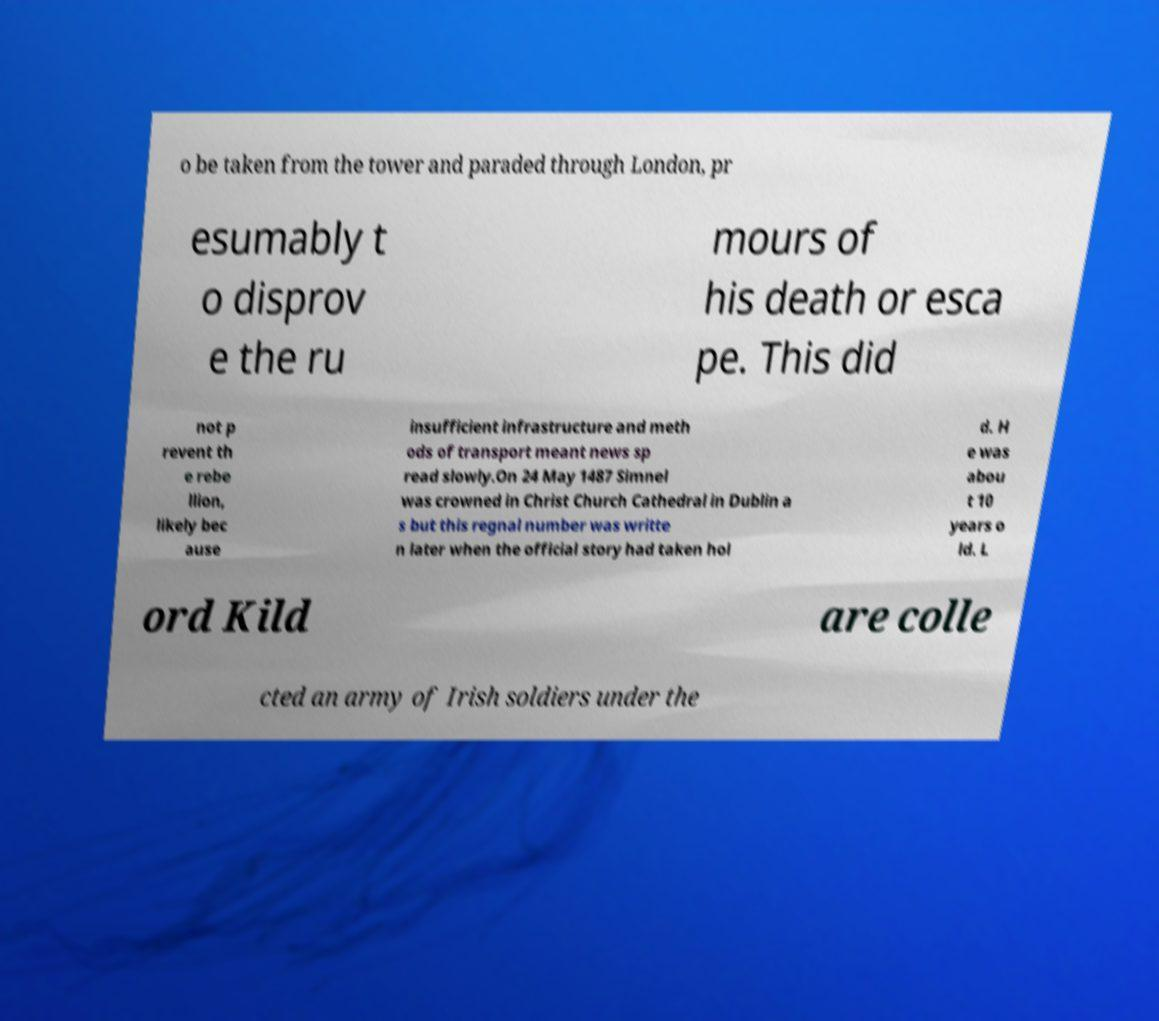Can you accurately transcribe the text from the provided image for me? o be taken from the tower and paraded through London, pr esumably t o disprov e the ru mours of his death or esca pe. This did not p revent th e rebe llion, likely bec ause insufficient infrastructure and meth ods of transport meant news sp read slowly.On 24 May 1487 Simnel was crowned in Christ Church Cathedral in Dublin a s but this regnal number was writte n later when the official story had taken hol d. H e was abou t 10 years o ld. L ord Kild are colle cted an army of Irish soldiers under the 